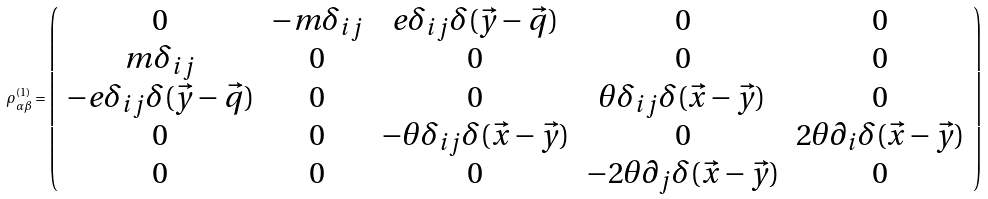Convert formula to latex. <formula><loc_0><loc_0><loc_500><loc_500>\rho _ { \alpha \beta } ^ { ( 1 ) } = \left ( \begin{array} { c c c c c } { 0 } & { { - m \delta _ { i j } } } & { { e \delta _ { i j } \delta ( \vec { y } - \vec { q } ) } } & { 0 } & { 0 } \\ { { m \delta _ { i j } } } & { 0 } & { 0 } & { 0 } & { 0 } \\ { { - e \delta _ { i j } \delta ( \vec { y } - \vec { q } ) } } & { 0 } & { 0 } & { { \theta \delta _ { i j } \delta ( \vec { x } - \vec { y } ) } } & { 0 } \\ { 0 } & { 0 } & { { - \theta \delta _ { i j } \delta ( \vec { x } - \vec { y } ) } } & { 0 } & { { 2 \theta \partial _ { i } \delta ( \vec { x } - \vec { y } ) } } \\ { 0 } & { 0 } & { 0 } & { { - 2 \theta \partial _ { j } \delta ( \vec { x } - \vec { y } ) } } & { 0 } \end{array} \right )</formula> 